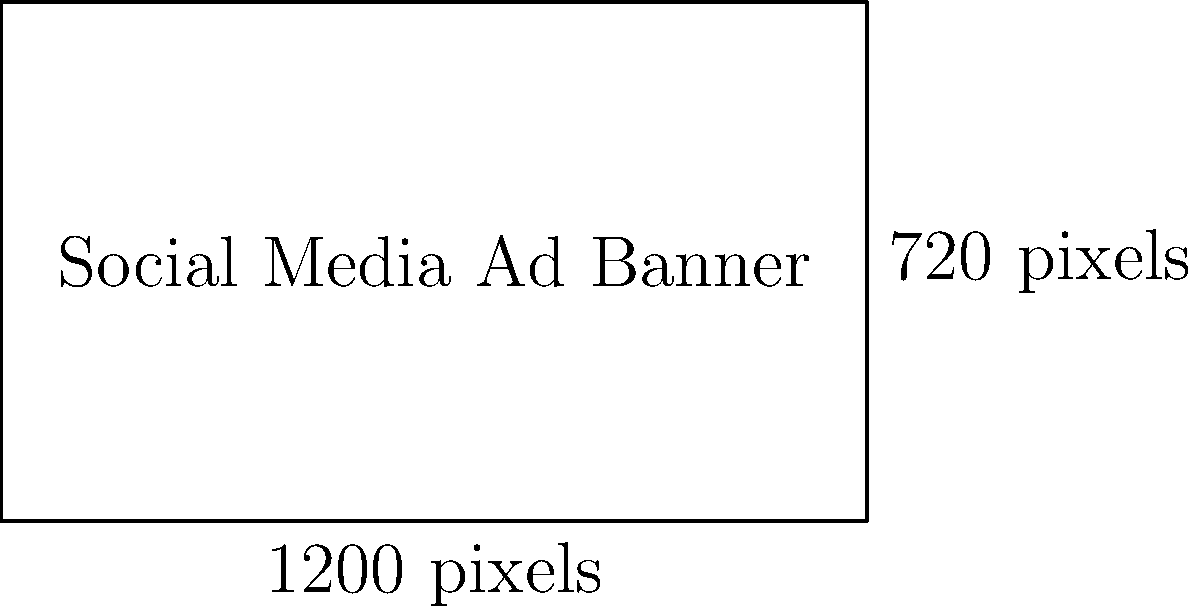As a social media marketing agency owner, you're designing a rectangular ad banner for a client's campaign. The banner's dimensions are 1200 pixels in length and 720 pixels in width. Calculate the total area of the ad banner in square pixels. How can this information be useful for your data-driven strategy? To calculate the area of a rectangular ad banner, we need to multiply its length by its width. Let's break it down step-by-step:

1. Identify the given dimensions:
   Length (l) = 1200 pixels
   Width (w) = 720 pixels

2. Apply the formula for the area of a rectangle:
   Area (A) = length × width
   A = l × w

3. Substitute the values:
   A = 1200 pixels × 720 pixels

4. Perform the multiplication:
   A = 864,000 square pixels

The total area of the ad banner is 864,000 square pixels.

This information can be useful for a data-driven strategy in several ways:
1. Optimizing file size: Knowing the total area helps in estimating the file size and optimizing it for faster loading times.
2. Comparing ad sizes: You can compare this banner's area with other ad formats to understand its relative visibility.
3. Calculating cost-per-pixel: If you're charged based on ad size, you can calculate the cost-per-pixel for different platforms.
4. Assessing visual impact: The area gives you an idea of the potential visual impact on different devices and screen sizes.
5. A/B testing: You can test different banner sizes and compare their performance relative to their areas.

By incorporating this data into your strategy, you can make informed decisions about ad design, placement, and budget allocation for maximum client ROI.
Answer: 864,000 square pixels 